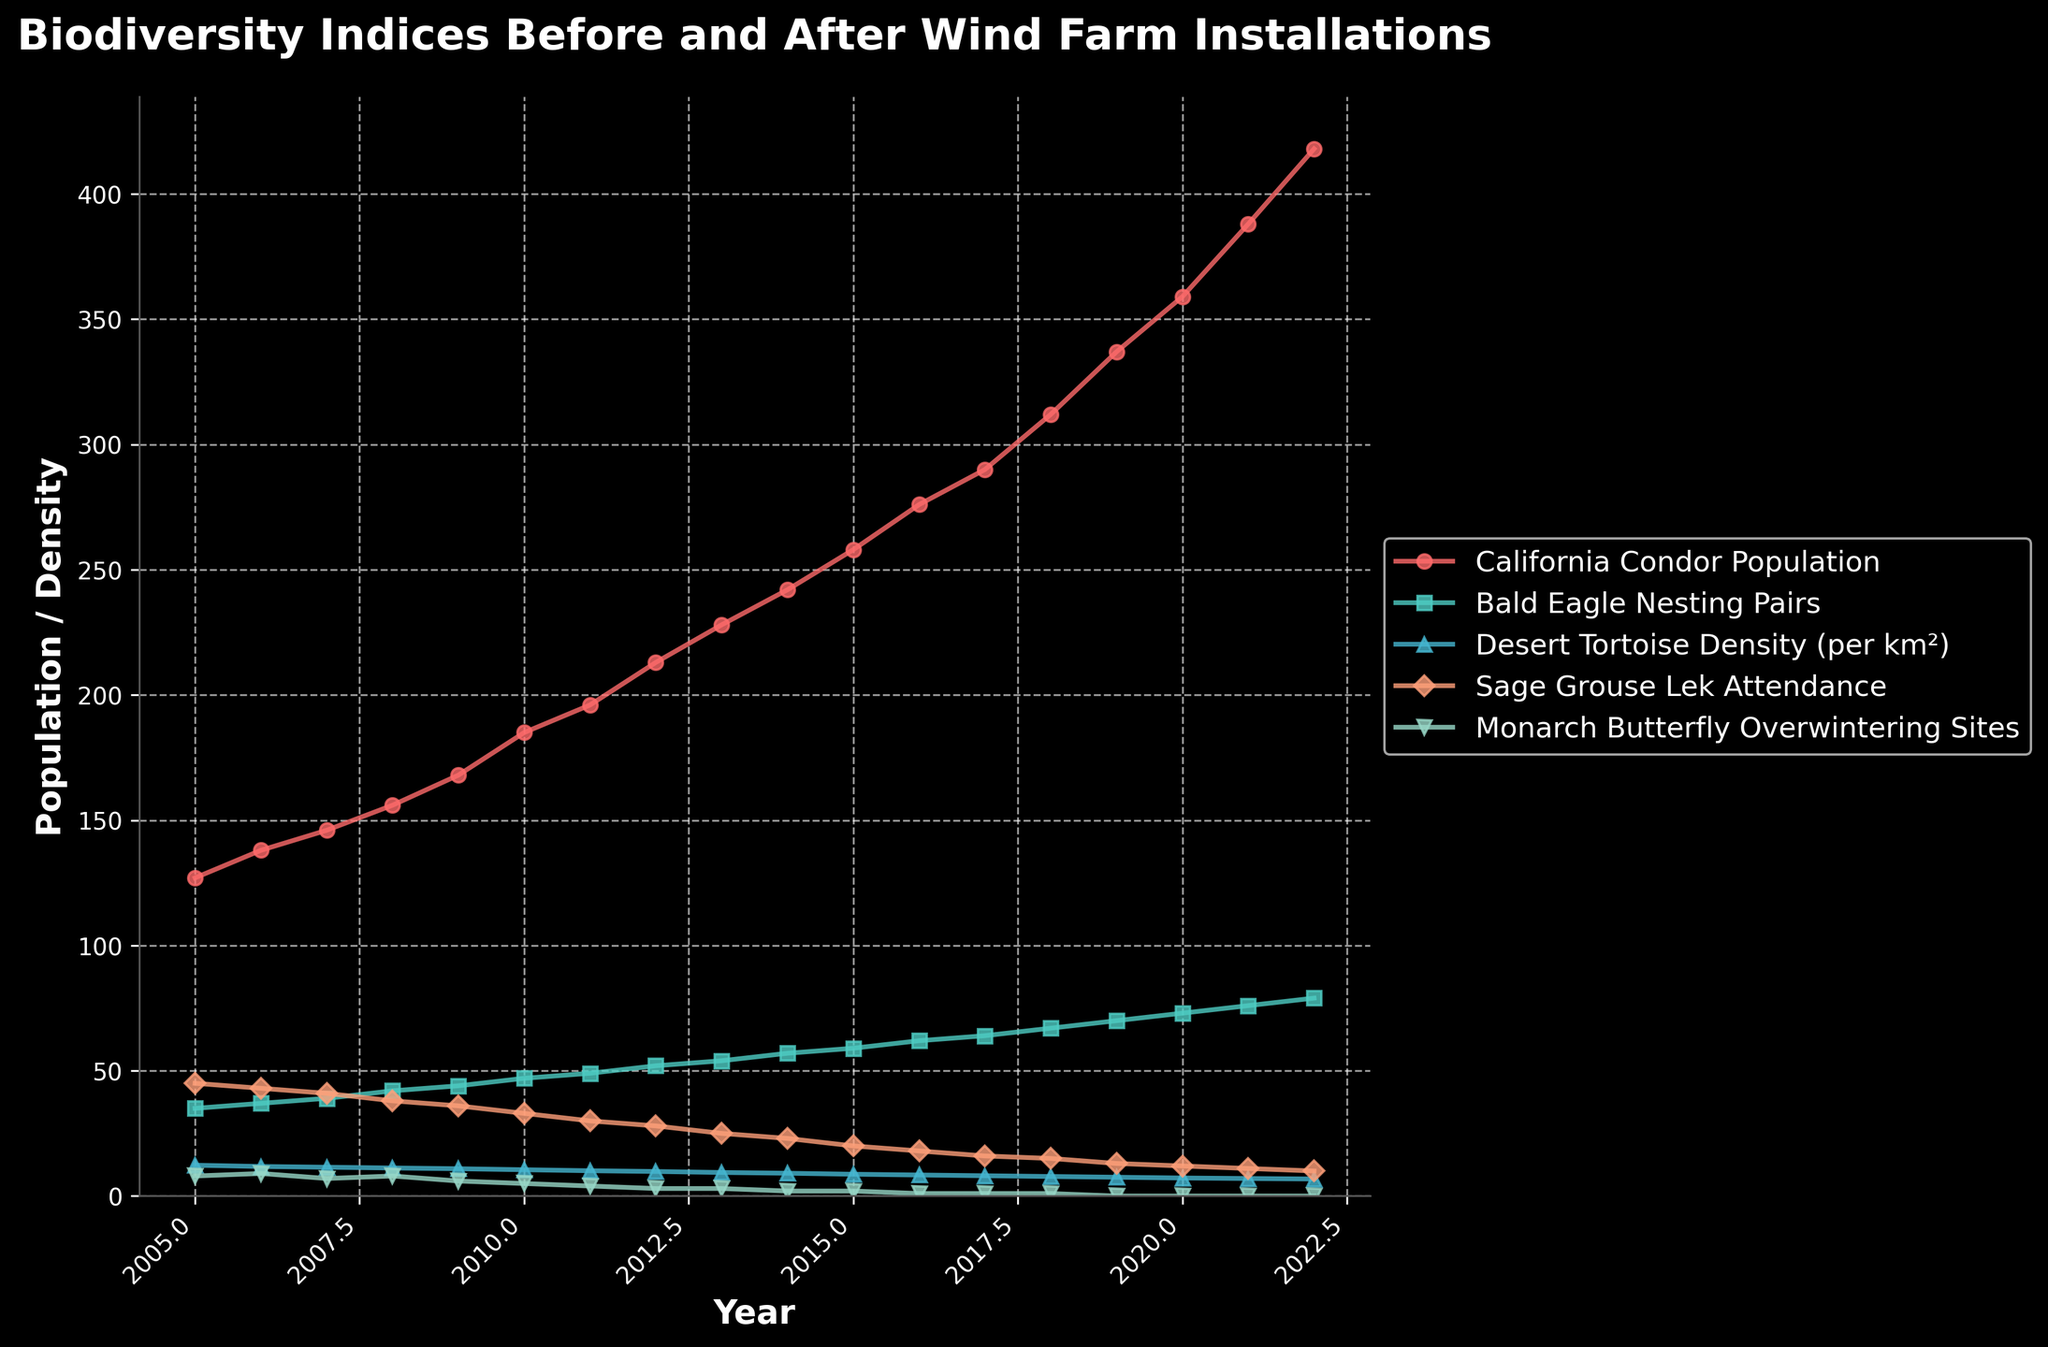What is the trend in the California Condor population from 2005 to 2022? The graph shows an upward trend in the California Condor population. Starting from 127 in 2005, the population increases steadily each year and reaches 418 in 2022.
Answer: Upward trend Which species shows a significant decline in density from 2005 to 2022? From the graph, the Desert Tortoise density shows a significant decline over the years. It decreases from 12.3 per km² in 2005 to 6.8 per km² in 2022.
Answer: Desert Tortoise Compare the lek attendance of Sage Grouse in 2005 and 2015. Which year was higher and by how much? In 2005, Sage Grouse lek attendance was 45, and it fell to 20 in 2015. The attendance was higher in 2005 by 25.
Answer: 2005 by 25 How does the Monarch Butterfly overwintering sites trend compare to the Bald Eagle nesting pairs from 2005 to 2022? The Monarch Butterfly overwintering sites trend shows a decline, starting from 8 sites in 2005 to 0 sites in 2022. In contrast, the Bald Eagle nesting pairs show an upward trend, increasing from 35 pairs in 2005 to 79 pairs in 2022.
Answer: Monarch Butterfly declines, Bald Eagle increases Calculate the average density of Desert Tortoise over the entire period. Add the densities from 2005 to 2022 and divide by the number of years: (12.3 + 11.8 + 11.5 + 11.2 + 10.9 + 10.5 + 10.1 + 9.8 + 9.4 + 9.1 + 8.7 + 8.4 + 8.1 + 7.8 + 7.5 + 7.2 + 7.0 + 6.8) / 18 = 9.36.
Answer: 9.36 Identify the year when California Condor population crossed 300. From the graph, the California Condor population crosses 300 in 2018.
Answer: 2018 Which species had zero counts in their respective indices by 2022? By 2022, both Sage Grouse lek attendance and Monarch Butterfly overwintering sites show a count of zero.
Answer: Sage Grouse and Monarch Butterfly Determine the overall change in Bald Eagle nesting pairs from 2005 to 2022. Subtract the number of Bald Eagle nesting pairs in 2005 from that in 2022: 79 - 35 = 44.
Answer: 44 What is the visual difference in how the population of California Condors and Monarch Butterflies are represented in the plot? The California Condor population is shown with a distinct upward slope and red color, while the Monarch Butterfly overwintering sites show a declining slope and green color, eventually reaching zero.
Answer: Upward slope and red vs. downward slope and green Which year did Sage Grouse lek attendance experience the sharpest decline? By examining the graph, the sharpest decline in Sage Grouse lek attendance appears to be between 2006 (43) and 2007 (41), continuing more rapidly into 2008 (38). Thus, the sharp decline initiates in 2007.
Answer: 2007 